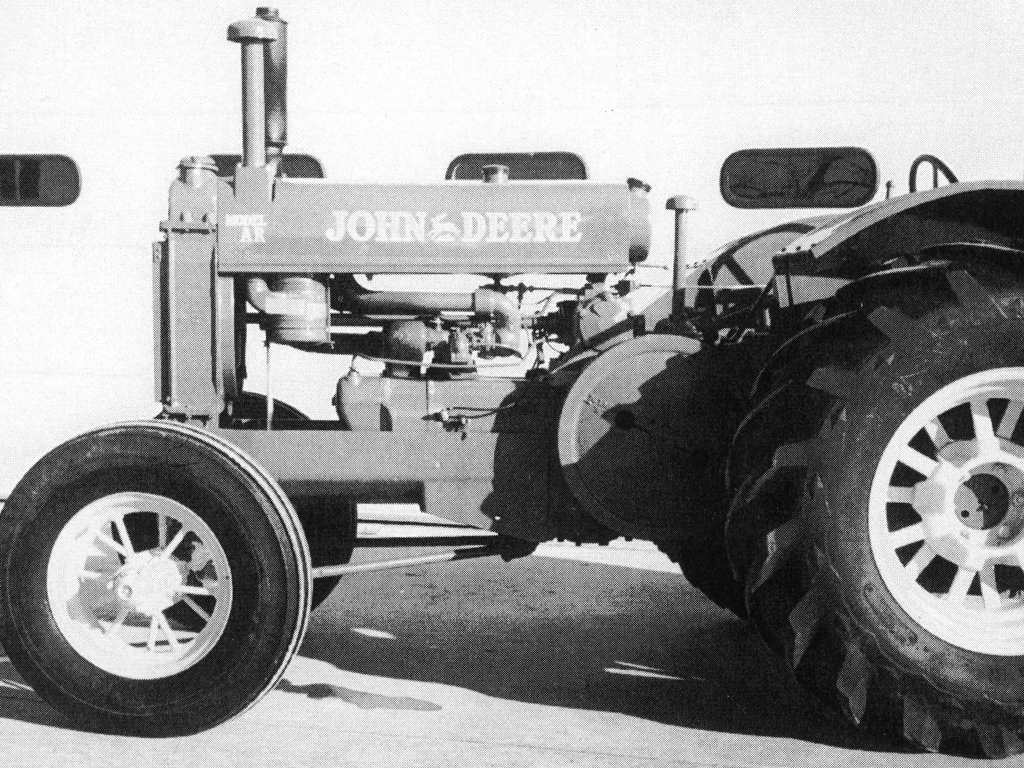Is the image of good quality? The image provided is in black and white, appears to be somewhat faded, and does not possess high definition quality by modern standards. Despite these limitations, the main subject, a vintage tractor, is distinguishable and the key features of the vehicle are visible, allowing for basic analysis and appreciation of the image's historical context. 